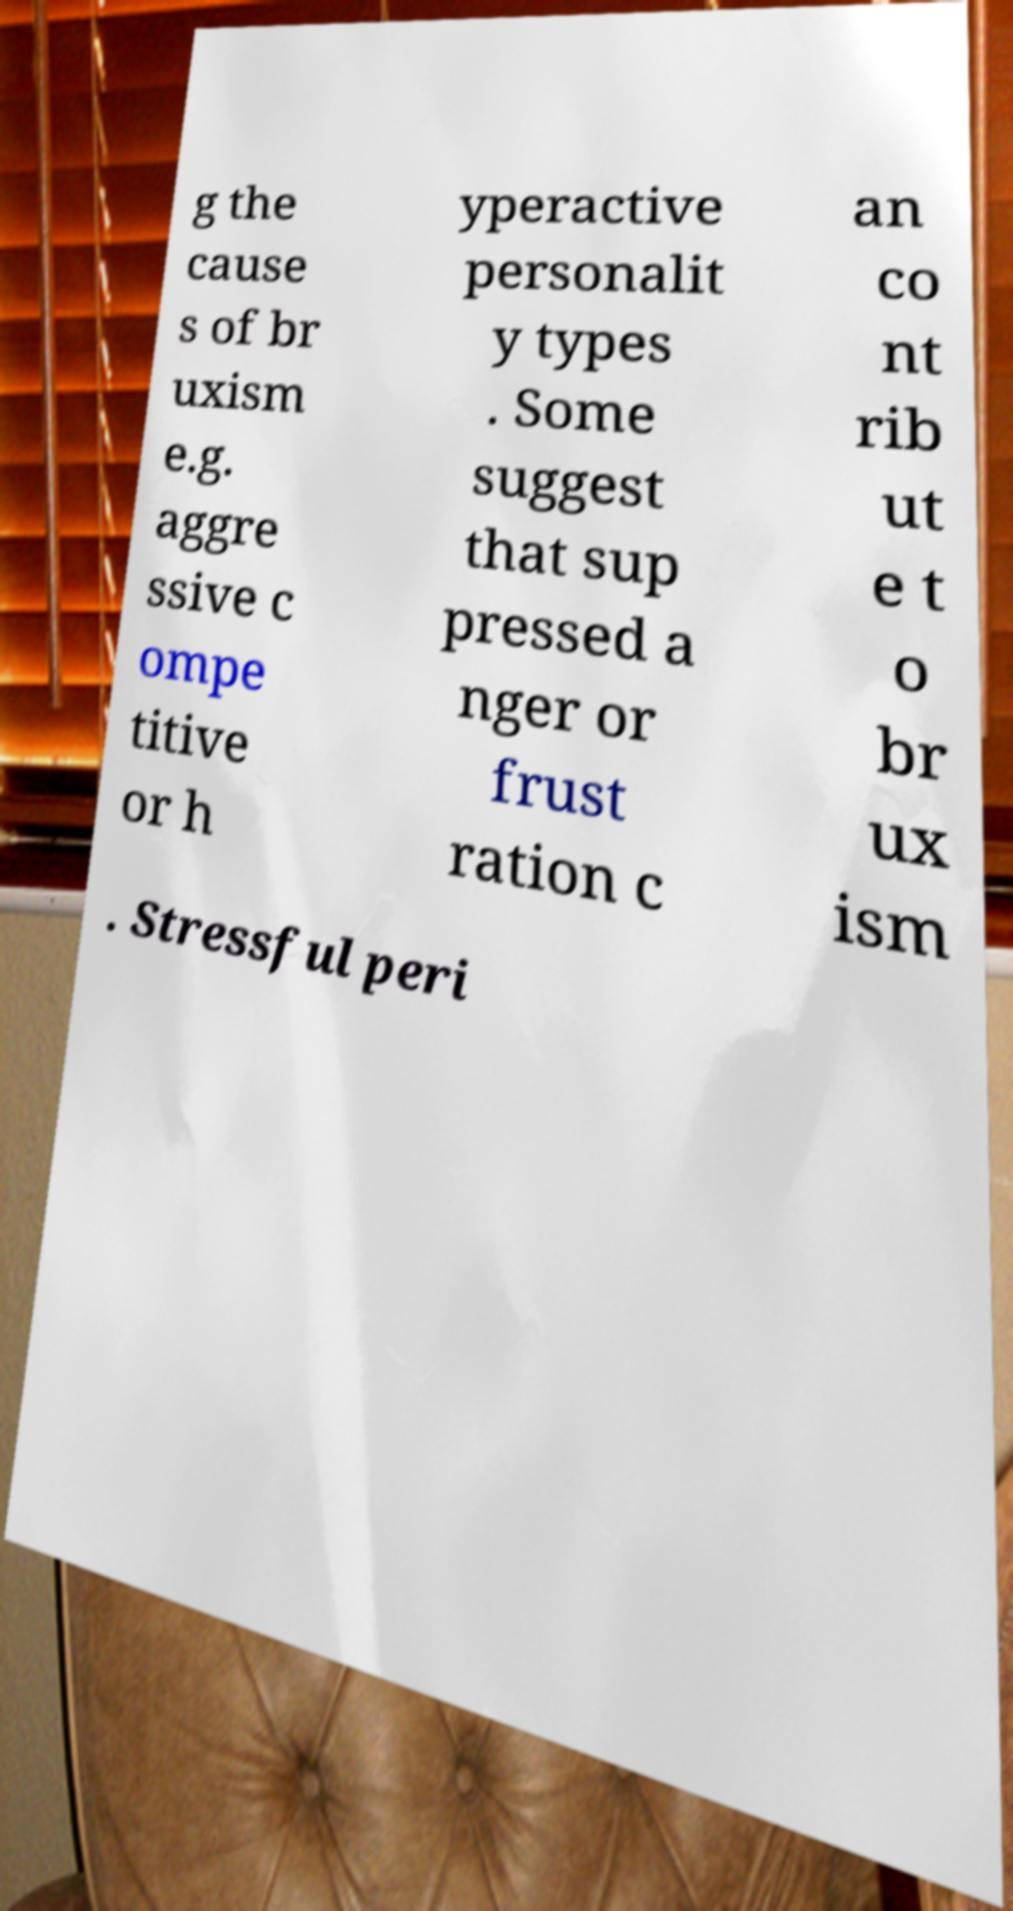Can you read and provide the text displayed in the image?This photo seems to have some interesting text. Can you extract and type it out for me? g the cause s of br uxism e.g. aggre ssive c ompe titive or h yperactive personalit y types . Some suggest that sup pressed a nger or frust ration c an co nt rib ut e t o br ux ism . Stressful peri 